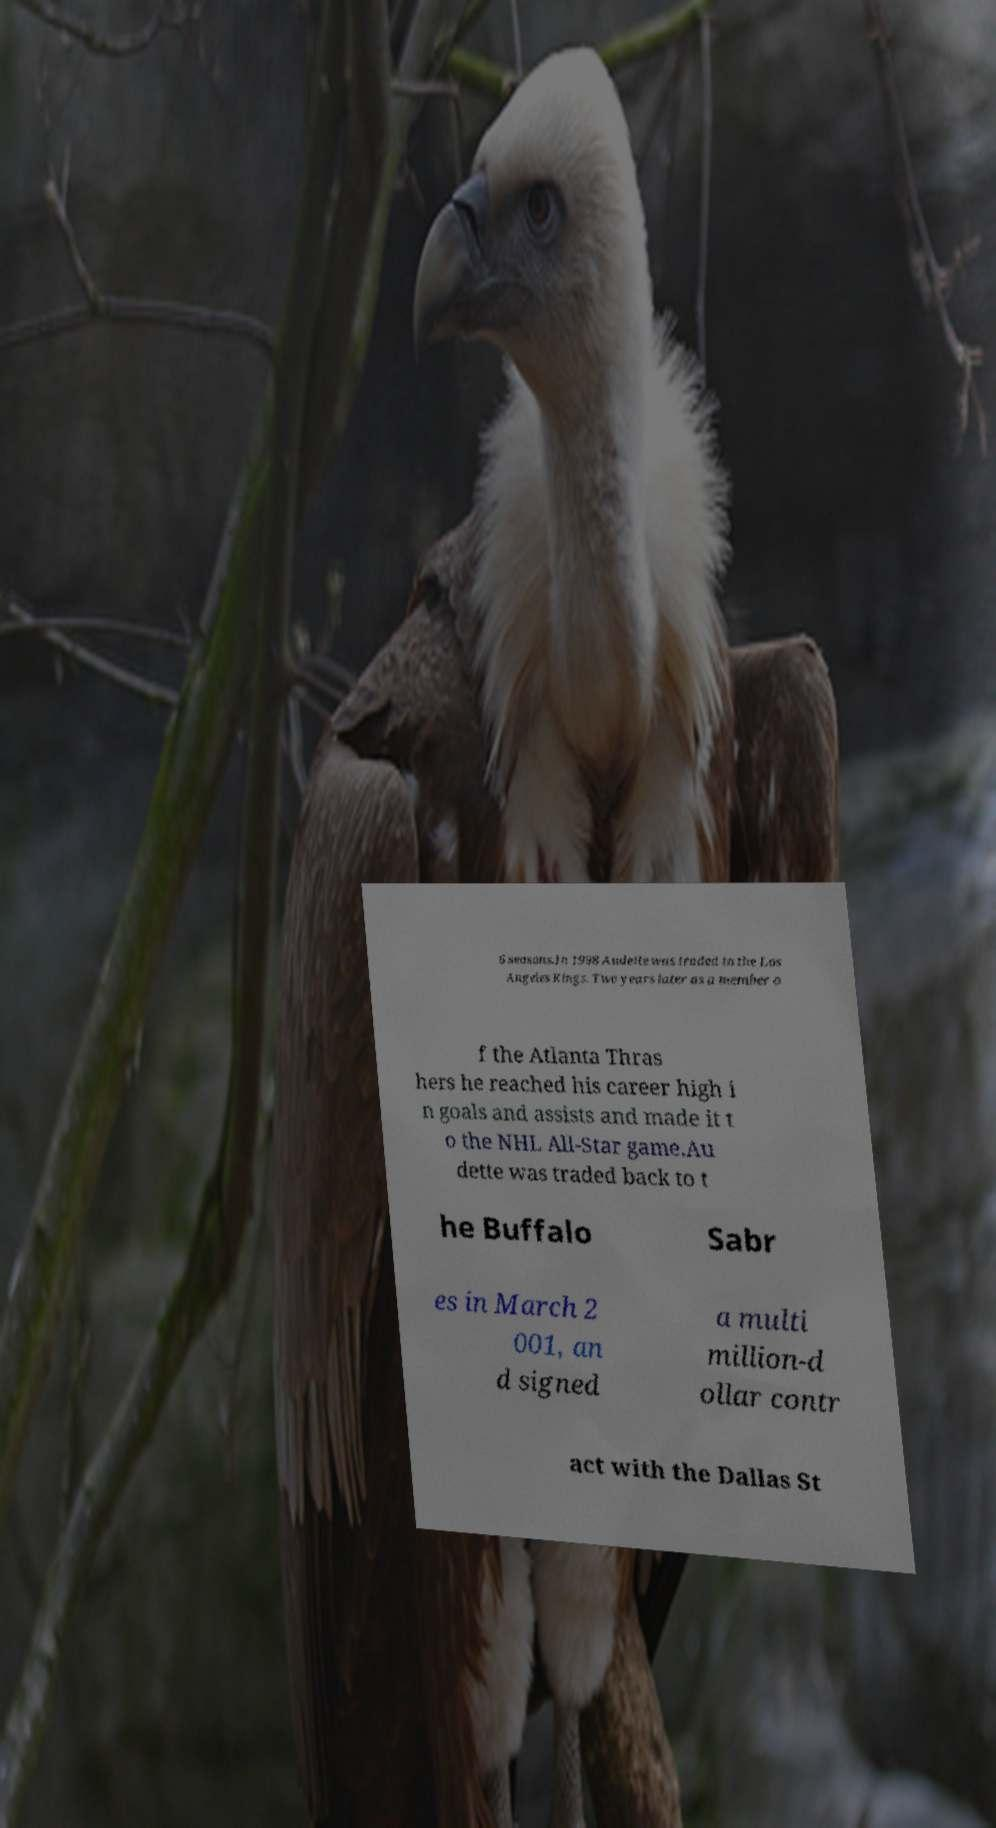There's text embedded in this image that I need extracted. Can you transcribe it verbatim? 6 seasons.In 1998 Audette was traded to the Los Angeles Kings. Two years later as a member o f the Atlanta Thras hers he reached his career high i n goals and assists and made it t o the NHL All-Star game.Au dette was traded back to t he Buffalo Sabr es in March 2 001, an d signed a multi million-d ollar contr act with the Dallas St 